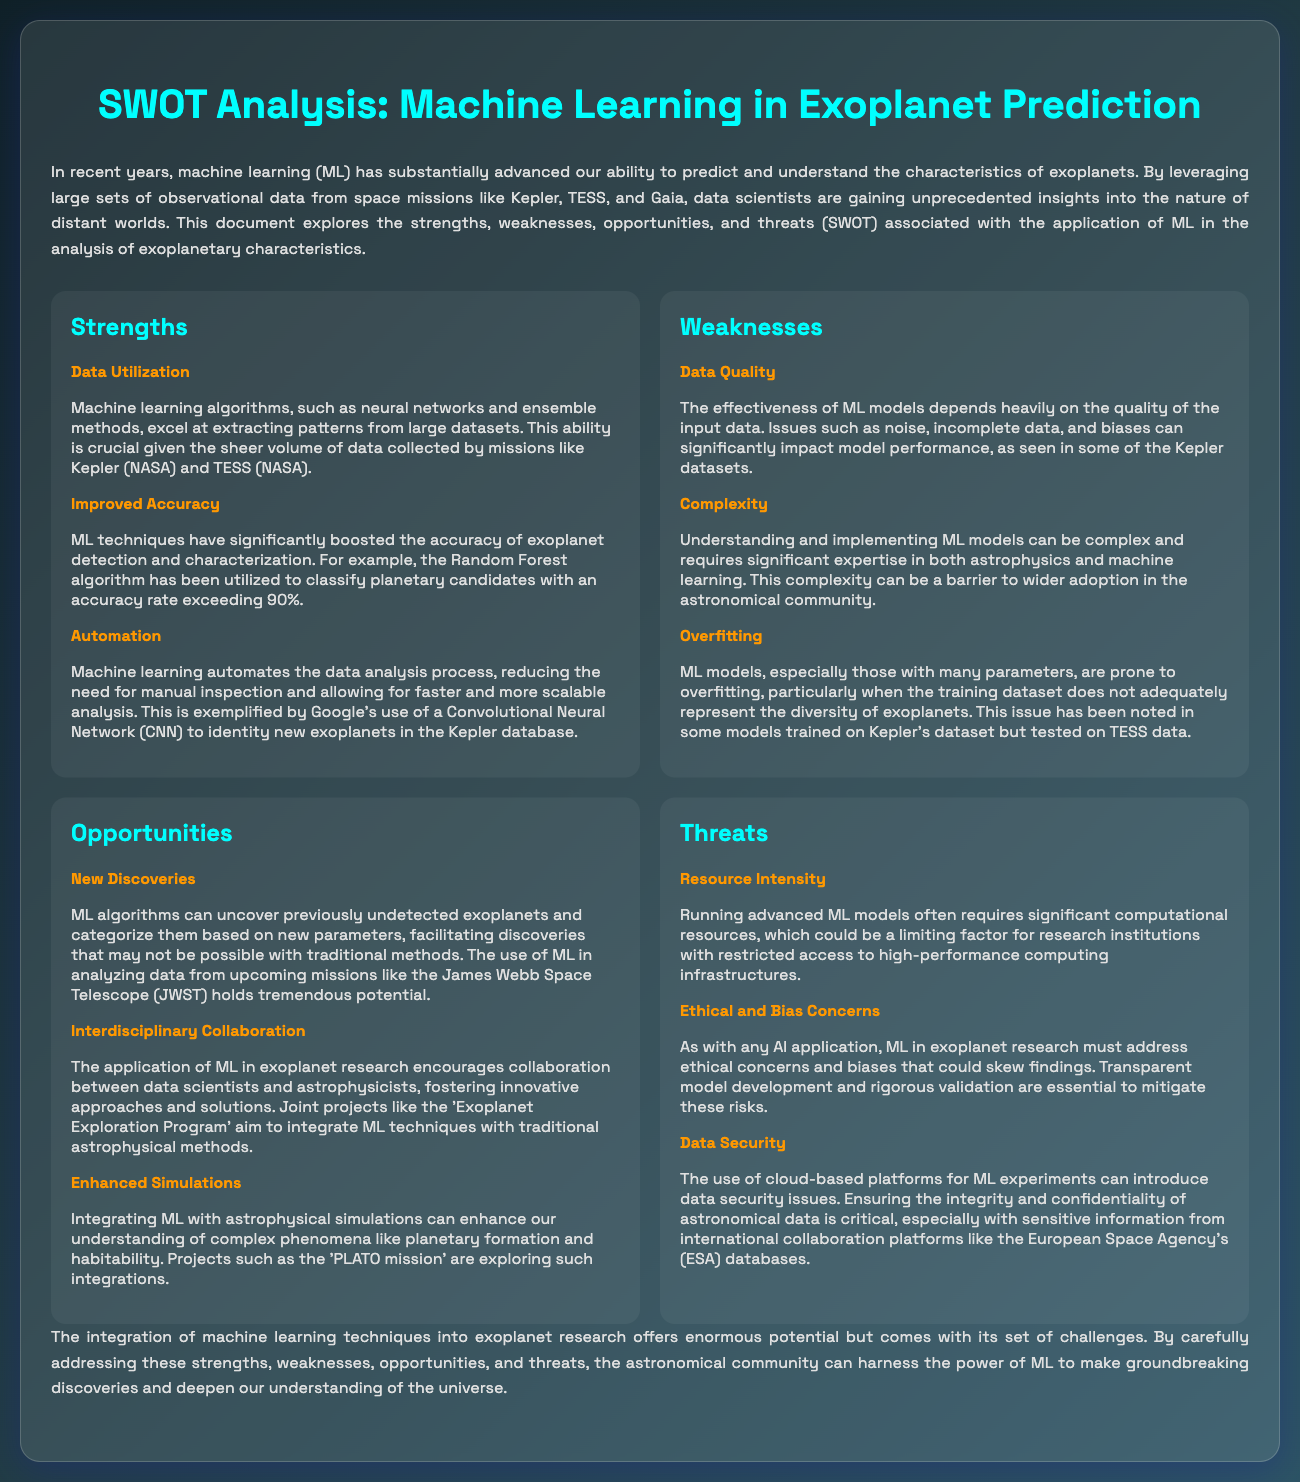What are the strengths of using machine learning in exoplanet prediction? The strengths include data utilization, improved accuracy, and automation as outlined in the strengths section of the document.
Answer: Data utilization, improved accuracy, automation What is the accuracy rate mentioned for the Random Forest algorithm? The document states that the Random Forest algorithm classifies planetary candidates with an accuracy exceeding 90%.
Answer: 90% What is a noted disadvantage of machine learning models mentioned in the weaknesses section? The weaknesses section highlights data quality, complexity, and overfitting as disadvantages of machine learning models.
Answer: Data quality What upcoming mission is mentioned in the opportunities section? The document refers to the James Webb Space Telescope as an upcoming mission with tremendous potential for ML applications in exoplanet research.
Answer: James Webb Space Telescope What ethical concern must ML in exoplanet research address? The document indicates that ML applications must address ethical concerns related to biases that could skew findings.
Answer: Bias concerns How can ML enhance our understanding of planetary phenomena? The document mentions that integrating ML with astrophysical simulations can enhance understanding of complex phenomena like planetary formation and habitability.
Answer: Enhancing simulations What major challenge does ML face regarding computational resources? The threat section discusses resource intensity as a limiting factor for research institutions due to the significant computational resources required.
Answer: Resource intensity What does the document describe as essential for mitigating risks in ML research? The document emphasizes that transparent model development and rigorous validation are essential for mitigating ethical and bias concerns in ML.
Answer: Transparent model development How does machine learning automate the data analysis process? The automation capability is exemplified by Google's use of a Convolutional Neural Network to identify new exoplanets in the Kepler database.
Answer: Convolutional Neural Network 